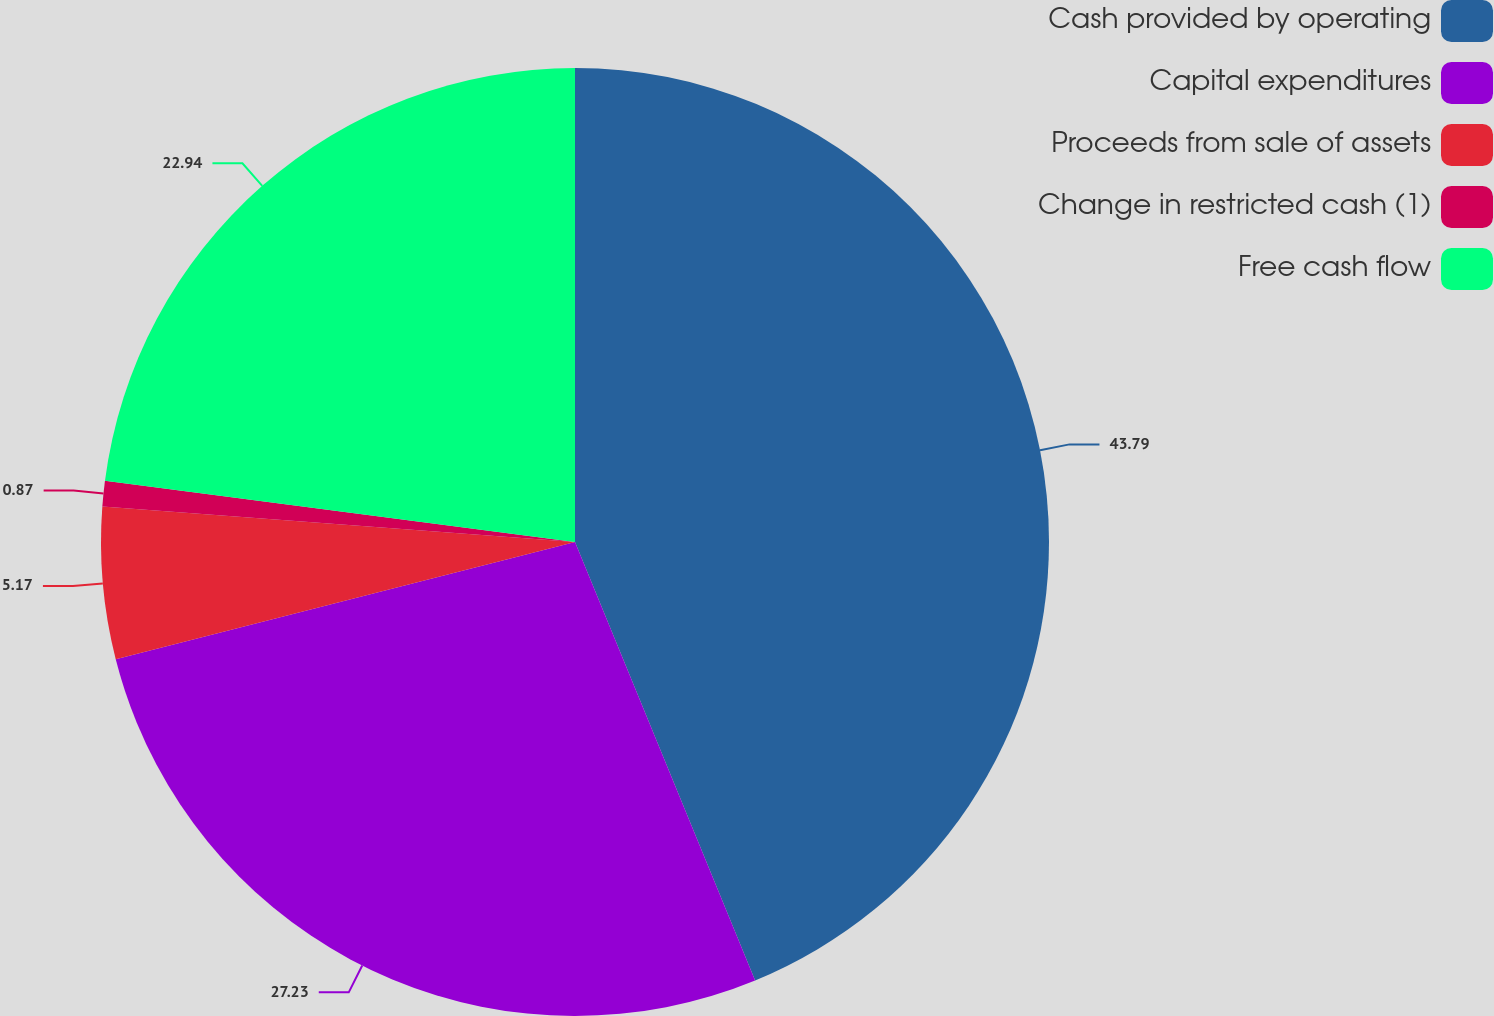Convert chart to OTSL. <chart><loc_0><loc_0><loc_500><loc_500><pie_chart><fcel>Cash provided by operating<fcel>Capital expenditures<fcel>Proceeds from sale of assets<fcel>Change in restricted cash (1)<fcel>Free cash flow<nl><fcel>43.8%<fcel>27.23%<fcel>5.17%<fcel>0.87%<fcel>22.94%<nl></chart> 